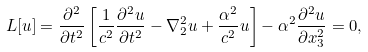Convert formula to latex. <formula><loc_0><loc_0><loc_500><loc_500>L [ u ] = \frac { \partial ^ { 2 } } { \partial t ^ { 2 } } \left [ \frac { 1 } { c ^ { 2 } } \frac { \partial ^ { 2 } u } { \partial t ^ { 2 } } - \nabla _ { 2 } ^ { 2 } u + \frac { \alpha ^ { 2 } } { c ^ { 2 } } u \right ] - \alpha ^ { 2 } \frac { \partial ^ { 2 } u } { \partial x _ { 3 } ^ { 2 } } = 0 ,</formula> 